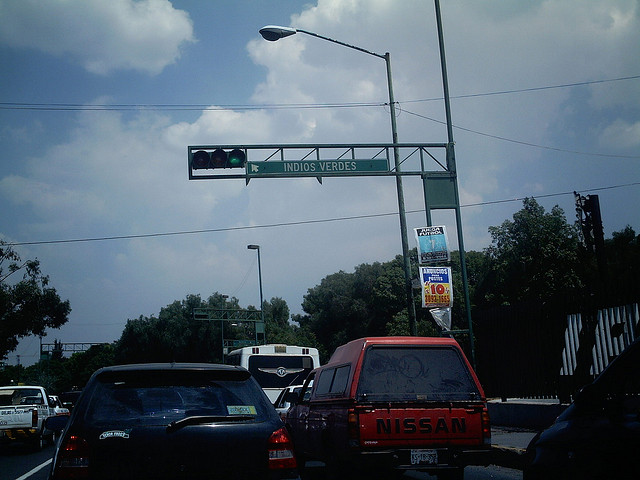What is the make of the red vehicle in the image? The red vehicle in the image is a Nissan truck. 